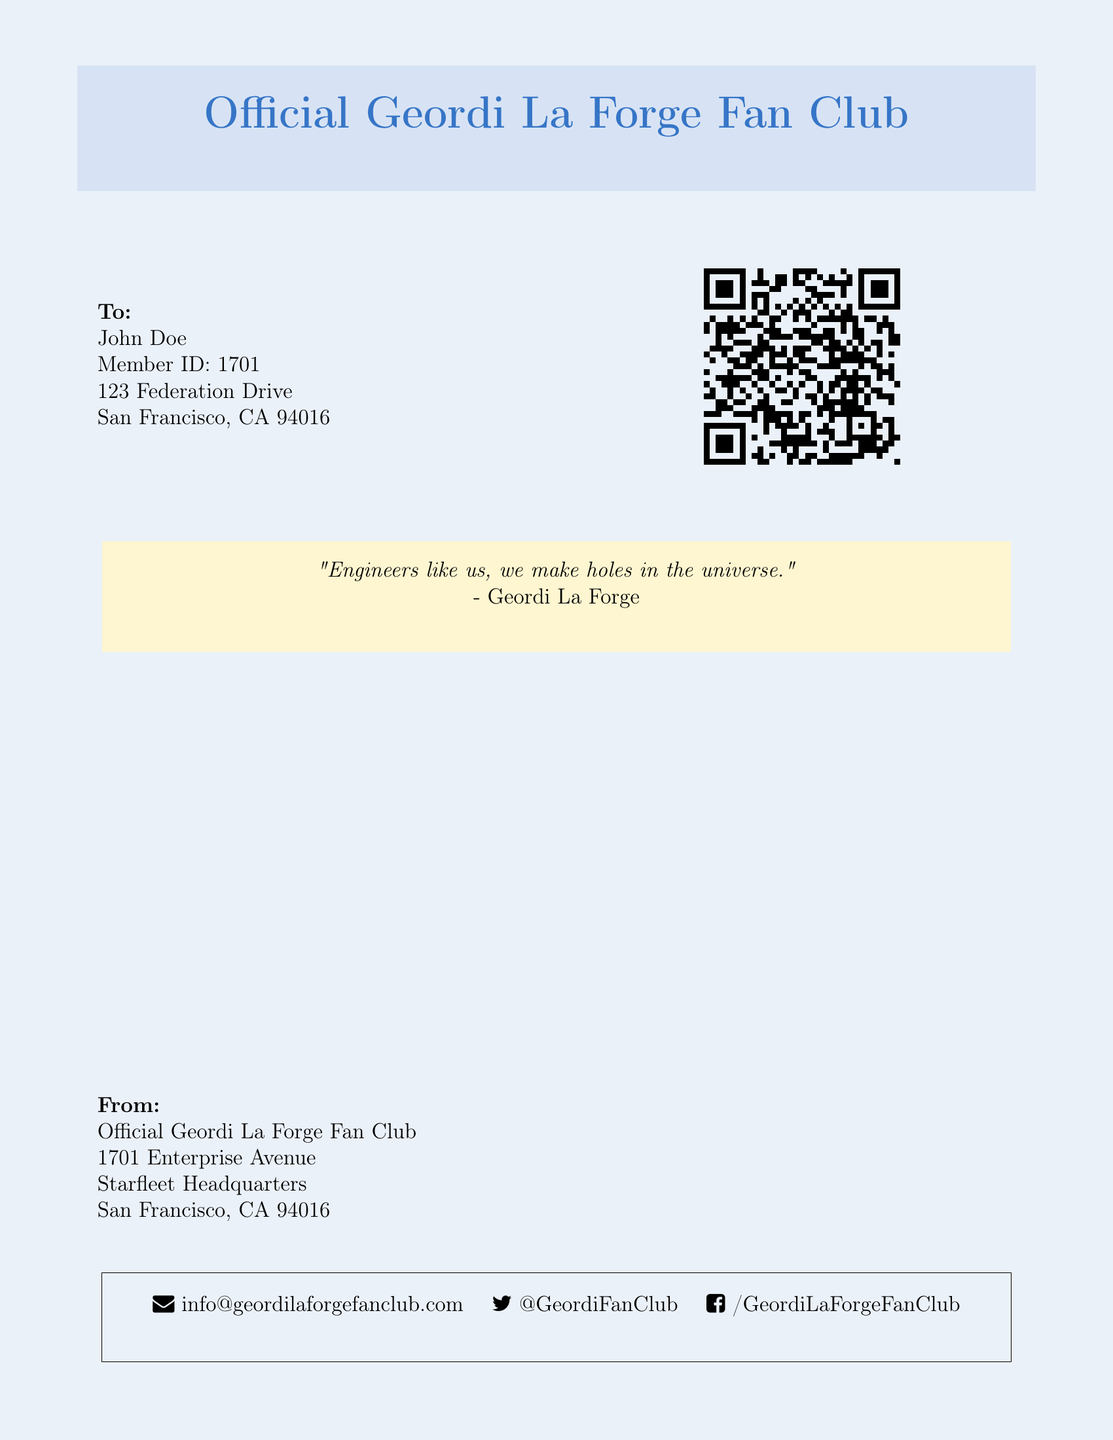What is the name of the fan club? The fan club is explicitly mentioned in the document.
Answer: Official Geordi La Forge Fan Club Who is the member of the fan club? The document specifies the name of the member to whom the envelope is addressed.
Answer: John Doe What is the member ID? The member ID is provided alongside the member's name.
Answer: 1701 What quote is included in the packet? The document contains a quote by Geordi La Forge, which is highlighted.
Answer: "Engineers like us, we make holes in the universe." What is the email address for the fan club? The document lists the email contact for the fan club.
Answer: info@geordilaforgefanclub.com What is the address of the fan club? The document provides the official address from where the fan club operates.
Answer: 1701 Enterprise Avenue What is the city of the fan club's address? The address of the fan club includes the name of the city as mentioned in the document.
Answer: San Francisco What social media platform is mentioned? The document includes contact information that indicates social media accounts.
Answer: Twitter What color is used for the quote box? The document uses a specific color scheme for highlighting quotes.
Answer: Gold 